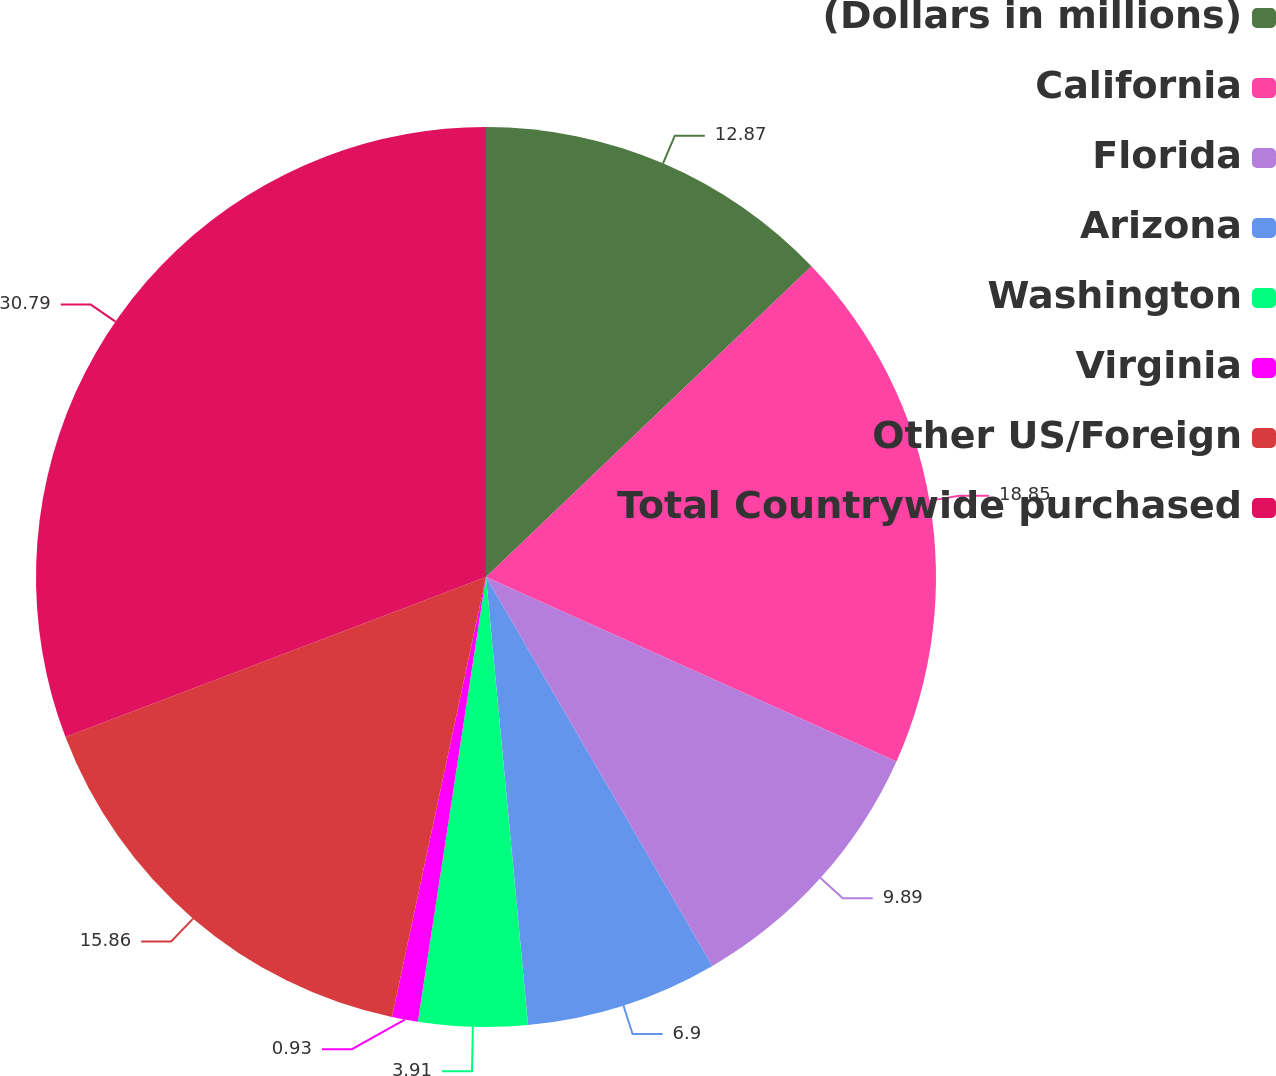Convert chart to OTSL. <chart><loc_0><loc_0><loc_500><loc_500><pie_chart><fcel>(Dollars in millions)<fcel>California<fcel>Florida<fcel>Arizona<fcel>Washington<fcel>Virginia<fcel>Other US/Foreign<fcel>Total Countrywide purchased<nl><fcel>12.87%<fcel>18.85%<fcel>9.89%<fcel>6.9%<fcel>3.91%<fcel>0.93%<fcel>15.86%<fcel>30.79%<nl></chart> 